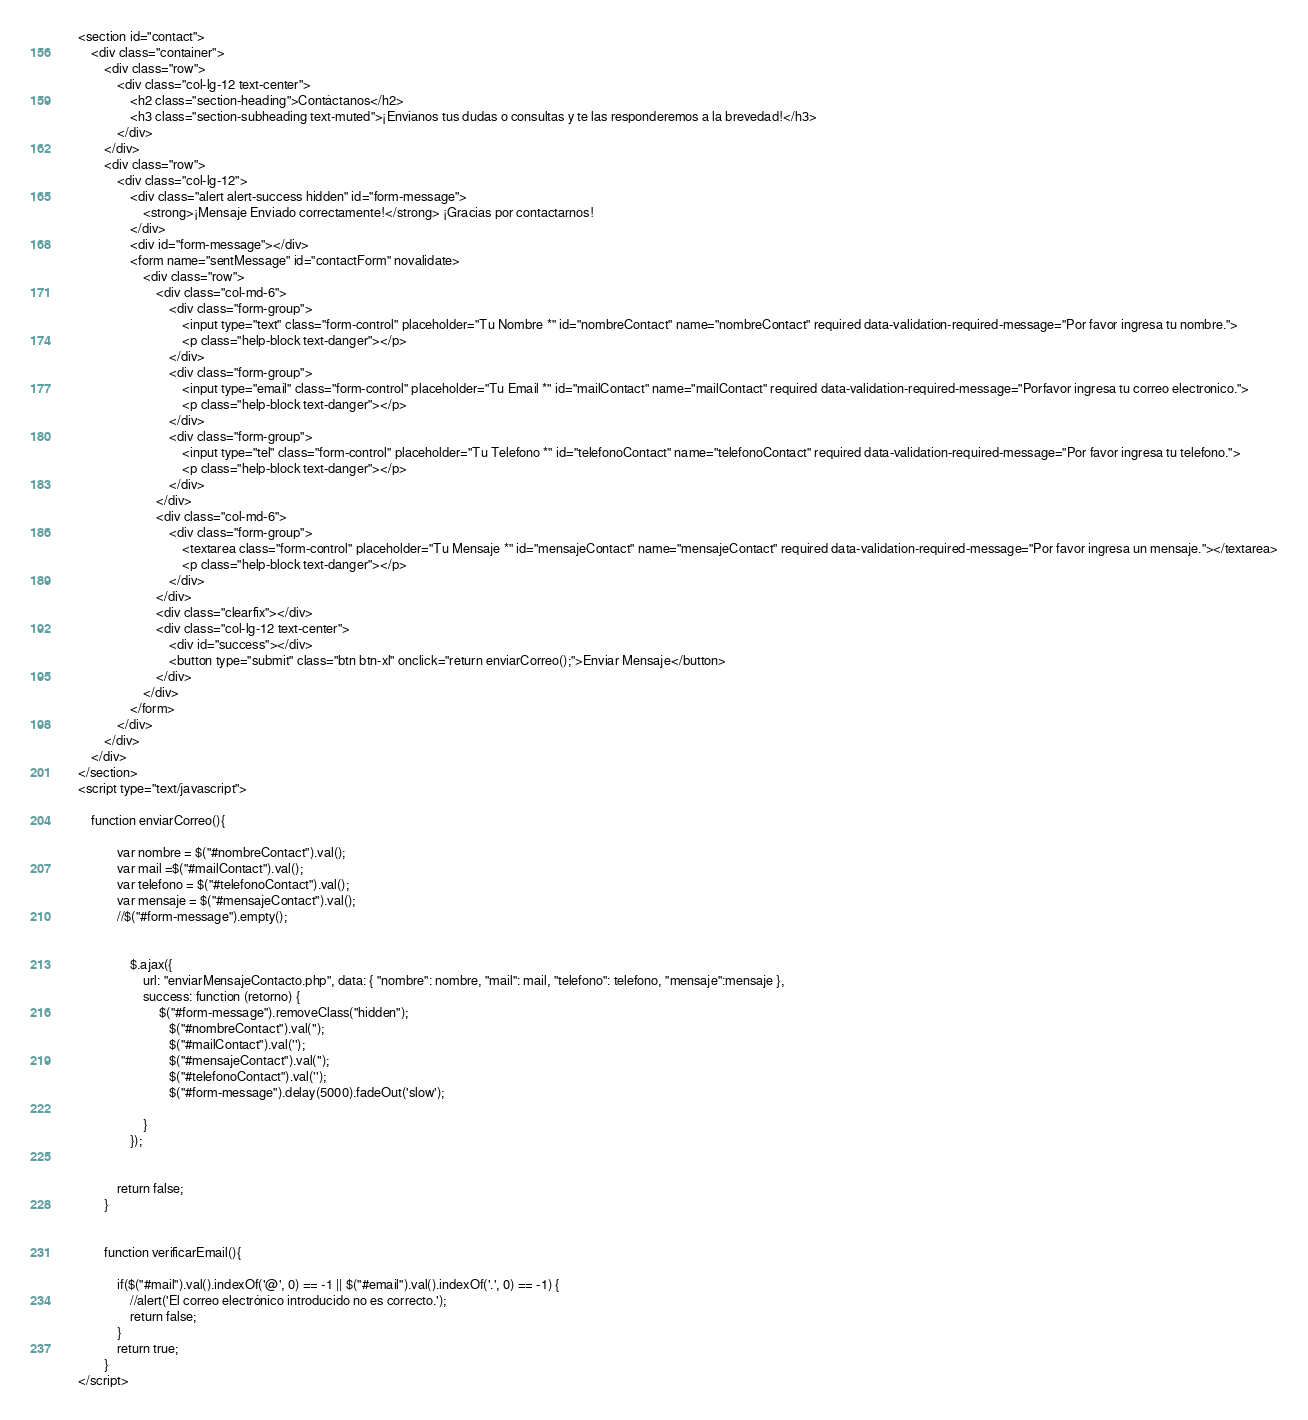Convert code to text. <code><loc_0><loc_0><loc_500><loc_500><_PHP_>
    <section id="contact">
        <div class="container">
            <div class="row">
                <div class="col-lg-12 text-center">
                    <h2 class="section-heading">Contáctanos</h2>
                    <h3 class="section-subheading text-muted">¡Envíanos tus dudas o consultas y te las responderemos a la brevedad!</h3>
                </div>
            </div>
            <div class="row">
                <div class="col-lg-12">
                    <div class="alert alert-success hidden" id="form-message">
                        <strong>¡Mensaje Enviado correctamente!</strong> ¡Gracias por contactarnos!
                    </div>
                    <div id="form-message"></div>
                    <form name="sentMessage" id="contactForm" novalidate>
                        <div class="row">
                            <div class="col-md-6">
                                <div class="form-group">
                                    <input type="text" class="form-control" placeholder="Tu Nombre *" id="nombreContact" name="nombreContact" required data-validation-required-message="Por favor ingresa tu nombre.">
                                    <p class="help-block text-danger"></p>
                                </div>
                                <div class="form-group">
                                    <input type="email" class="form-control" placeholder="Tu Email *" id="mailContact" name="mailContact" required data-validation-required-message="Porfavor ingresa tu correo electronico.">
                                    <p class="help-block text-danger"></p>
                                </div>
                                <div class="form-group">
                                    <input type="tel" class="form-control" placeholder="Tu Telefono *" id="telefonoContact" name="telefonoContact" required data-validation-required-message="Por favor ingresa tu telefono.">
                                    <p class="help-block text-danger"></p>
                                </div>
                            </div>
                            <div class="col-md-6">
                                <div class="form-group">
                                    <textarea class="form-control" placeholder="Tu Mensaje *" id="mensajeContact" name="mensajeContact" required data-validation-required-message="Por favor ingresa un mensaje."></textarea>
                                    <p class="help-block text-danger"></p>
                                </div>
                            </div>
                            <div class="clearfix"></div>
                            <div class="col-lg-12 text-center">
                                <div id="success"></div>
                                <button type="submit" class="btn btn-xl" onclick="return enviarCorreo();">Enviar Mensaje</button>
                            </div>
                        </div>
                    </form>
                </div>
            </div>
        </div>
    </section>
    <script type="text/javascript">
        
        function enviarCorreo(){

                var nombre = $("#nombreContact").val();
                var mail =$("#mailContact").val();
                var telefono = $("#telefonoContact").val();  
                var mensaje = $("#mensajeContact").val();                  
                //$("#form-message").empty();    
                
                
                    $.ajax({
                        url: "enviarMensajeContacto.php", data: { "nombre": nombre, "mail": mail, "telefono": telefono, "mensaje":mensaje },
                        success: function (retorno) {  
                             $("#form-message").removeClass("hidden");
                                $("#nombreContact").val('');
                                $("#mailContact").val('');
                                $("#mensajeContact").val(''); 
                                $("#telefonoContact").val(''); 
                                $("#form-message").delay(5000).fadeOut('slow');
                
                        }
                    });
                            
                
                return false;
            }


            function verificarEmail(){

                if($("#mail").val().indexOf('@', 0) == -1 || $("#email").val().indexOf('.', 0) == -1) {
                    //alert('El correo electrónico introducido no es correcto.');
                    return false;
                }
                return true;
            }
    </script></code> 